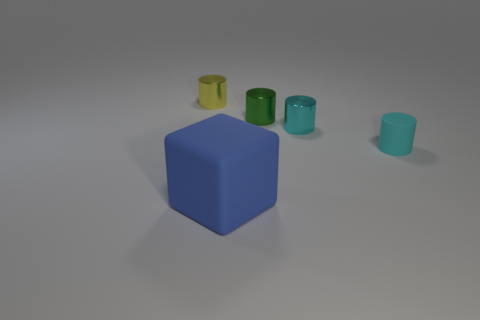Is there anything else that is the same shape as the large rubber thing?
Make the answer very short. No. There is a cyan object that is left of the tiny cyan matte cylinder; what is its material?
Your answer should be compact. Metal. There is a metal thing left of the object in front of the cyan matte cylinder; how big is it?
Your answer should be very brief. Small. Is there a sphere that has the same material as the yellow cylinder?
Ensure brevity in your answer.  No. What is the shape of the object in front of the tiny cylinder to the right of the tiny shiny object that is in front of the small green thing?
Keep it short and to the point. Cube. There is a shiny thing in front of the green cylinder; is its color the same as the rubber object that is to the right of the green thing?
Your answer should be very brief. Yes. Is there anything else that is the same size as the blue cube?
Give a very brief answer. No. Are there any tiny shiny cylinders left of the cube?
Your response must be concise. Yes. What number of other tiny cyan things are the same shape as the tiny cyan matte thing?
Offer a terse response. 1. What color is the tiny thing to the left of the rubber object to the left of the small metallic object that is on the right side of the tiny green object?
Offer a terse response. Yellow. 